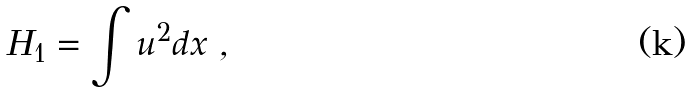Convert formula to latex. <formula><loc_0><loc_0><loc_500><loc_500>H _ { 1 } = \int u ^ { 2 } d x \ ,</formula> 